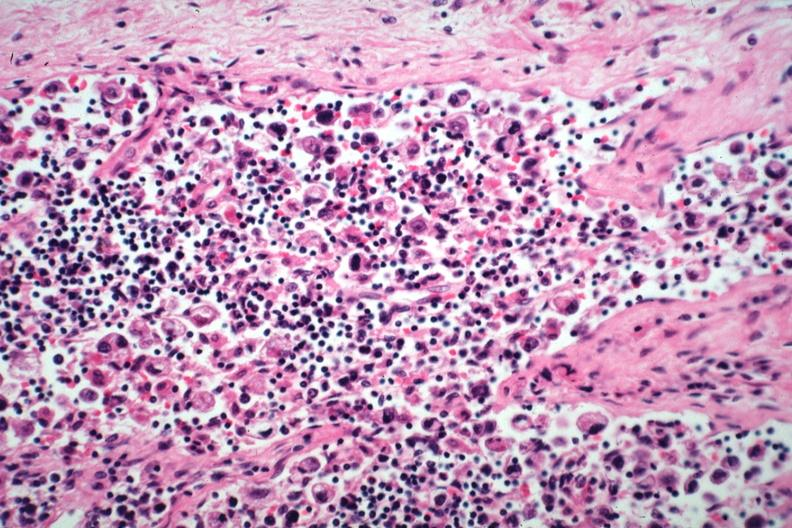what is present?
Answer the question using a single word or phrase. Lymph node 